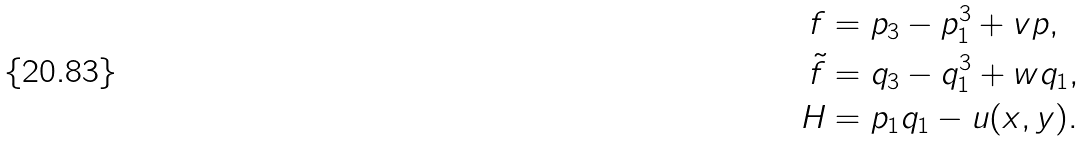Convert formula to latex. <formula><loc_0><loc_0><loc_500><loc_500>f & = p _ { 3 } - p _ { 1 } ^ { 3 } + v p , \\ \tilde { f } & = q _ { 3 } - q _ { 1 } ^ { 3 } + w q _ { 1 } , \\ H & = p _ { 1 } q _ { 1 } - u ( x , y ) .</formula> 